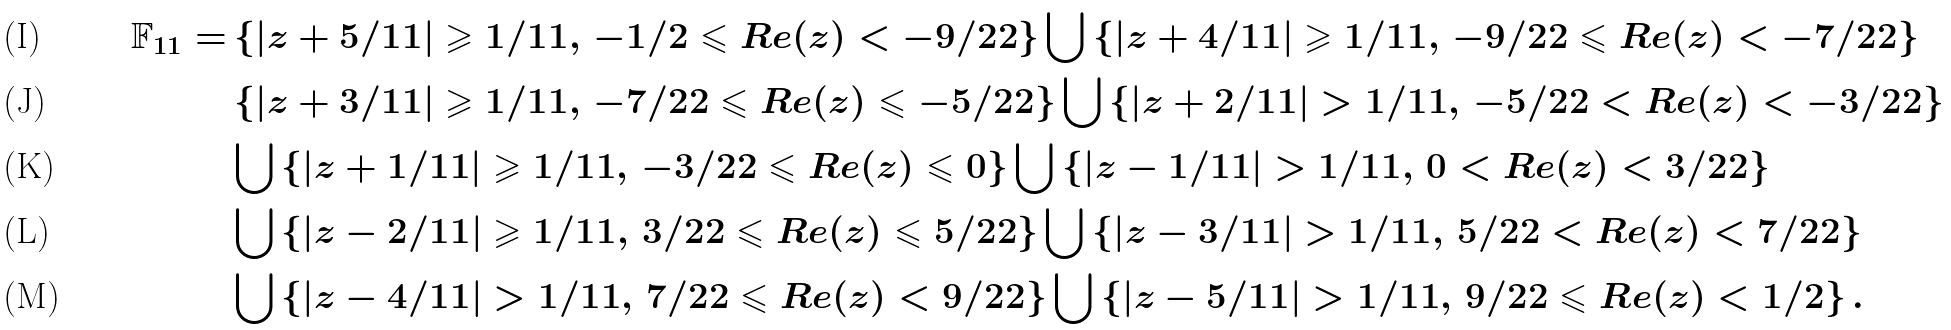Convert formula to latex. <formula><loc_0><loc_0><loc_500><loc_500>\mathbb { F } _ { 1 1 } = & \left \{ | z + 5 / 1 1 | \geqslant 1 / 1 1 , \, - 1 / 2 \leqslant R e ( z ) < - 9 / 2 2 \right \} \bigcup \left \{ | z + 4 / 1 1 | \geqslant 1 / 1 1 , \, - 9 / 2 2 \leqslant R e ( z ) < - 7 / 2 2 \right \} \\ & \left \{ | z + 3 / 1 1 | \geqslant 1 / 1 1 , \, - 7 / 2 2 \leqslant R e ( z ) \leqslant - 5 / 2 2 \right \} \bigcup \left \{ | z + 2 / 1 1 | > 1 / 1 1 , \, - 5 / 2 2 < R e ( z ) < - 3 / 2 2 \right \} \\ & \bigcup \left \{ | z + 1 / 1 1 | \geqslant 1 / 1 1 , \, - 3 / 2 2 \leqslant R e ( z ) \leqslant 0 \right \} \bigcup \left \{ | z - 1 / 1 1 | > 1 / 1 1 , \, 0 < R e ( z ) < 3 / 2 2 \right \} \\ & \bigcup \left \{ | z - 2 / 1 1 | \geqslant 1 / 1 1 , \, 3 / 2 2 \leqslant R e ( z ) \leqslant 5 / 2 2 \right \} \bigcup \left \{ | z - 3 / 1 1 | > 1 / 1 1 , \, 5 / 2 2 < R e ( z ) < 7 / 2 2 \right \} \\ & \bigcup \left \{ | z - 4 / 1 1 | > 1 / 1 1 , \, 7 / 2 2 \leqslant R e ( z ) < 9 / 2 2 \right \} \bigcup \left \{ | z - 5 / 1 1 | > 1 / 1 1 , \, 9 / 2 2 \leqslant R e ( z ) < 1 / 2 \right \} .</formula> 